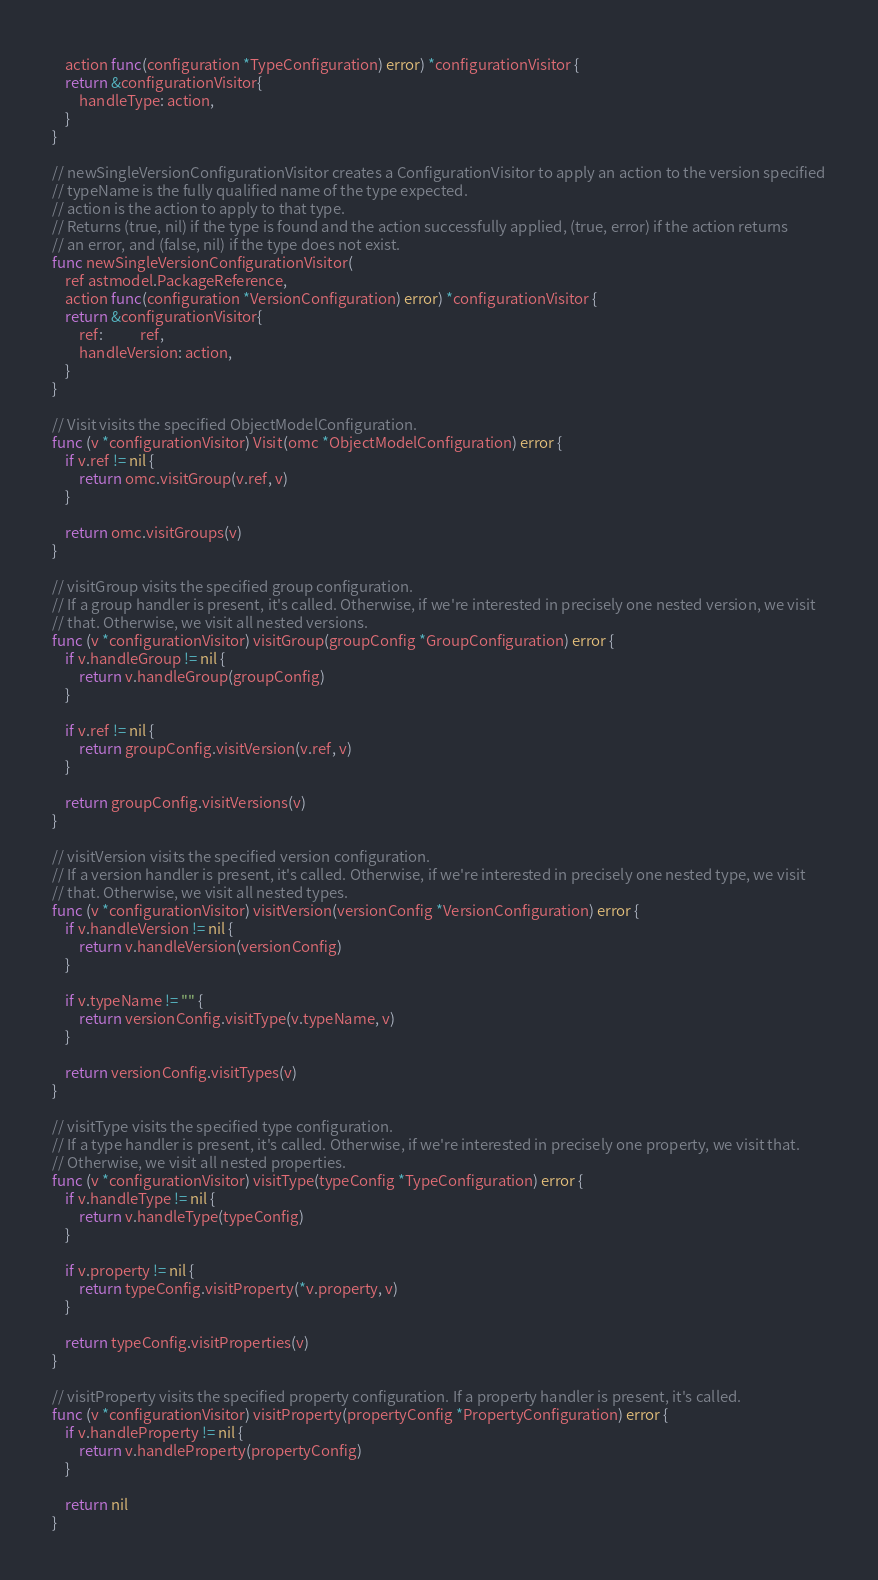Convert code to text. <code><loc_0><loc_0><loc_500><loc_500><_Go_>	action func(configuration *TypeConfiguration) error) *configurationVisitor {
	return &configurationVisitor{
		handleType: action,
	}
}

// newSingleVersionConfigurationVisitor creates a ConfigurationVisitor to apply an action to the version specified
// typeName is the fully qualified name of the type expected.
// action is the action to apply to that type.
// Returns (true, nil) if the type is found and the action successfully applied, (true, error) if the action returns
// an error, and (false, nil) if the type does not exist.
func newSingleVersionConfigurationVisitor(
	ref astmodel.PackageReference,
	action func(configuration *VersionConfiguration) error) *configurationVisitor {
	return &configurationVisitor{
		ref:           ref,
		handleVersion: action,
	}
}

// Visit visits the specified ObjectModelConfiguration.
func (v *configurationVisitor) Visit(omc *ObjectModelConfiguration) error {
	if v.ref != nil {
		return omc.visitGroup(v.ref, v)
	}

	return omc.visitGroups(v)
}

// visitGroup visits the specified group configuration.
// If a group handler is present, it's called. Otherwise, if we're interested in precisely one nested version, we visit
// that. Otherwise, we visit all nested versions.
func (v *configurationVisitor) visitGroup(groupConfig *GroupConfiguration) error {
	if v.handleGroup != nil {
		return v.handleGroup(groupConfig)
	}

	if v.ref != nil {
		return groupConfig.visitVersion(v.ref, v)
	}

	return groupConfig.visitVersions(v)
}

// visitVersion visits the specified version configuration.
// If a version handler is present, it's called. Otherwise, if we're interested in precisely one nested type, we visit
// that. Otherwise, we visit all nested types.
func (v *configurationVisitor) visitVersion(versionConfig *VersionConfiguration) error {
	if v.handleVersion != nil {
		return v.handleVersion(versionConfig)
	}

	if v.typeName != "" {
		return versionConfig.visitType(v.typeName, v)
	}

	return versionConfig.visitTypes(v)
}

// visitType visits the specified type configuration.
// If a type handler is present, it's called. Otherwise, if we're interested in precisely one property, we visit that.
// Otherwise, we visit all nested properties.
func (v *configurationVisitor) visitType(typeConfig *TypeConfiguration) error {
	if v.handleType != nil {
		return v.handleType(typeConfig)
	}

	if v.property != nil {
		return typeConfig.visitProperty(*v.property, v)
	}

	return typeConfig.visitProperties(v)
}

// visitProperty visits the specified property configuration. If a property handler is present, it's called.
func (v *configurationVisitor) visitProperty(propertyConfig *PropertyConfiguration) error {
	if v.handleProperty != nil {
		return v.handleProperty(propertyConfig)
	}

	return nil
}
</code> 